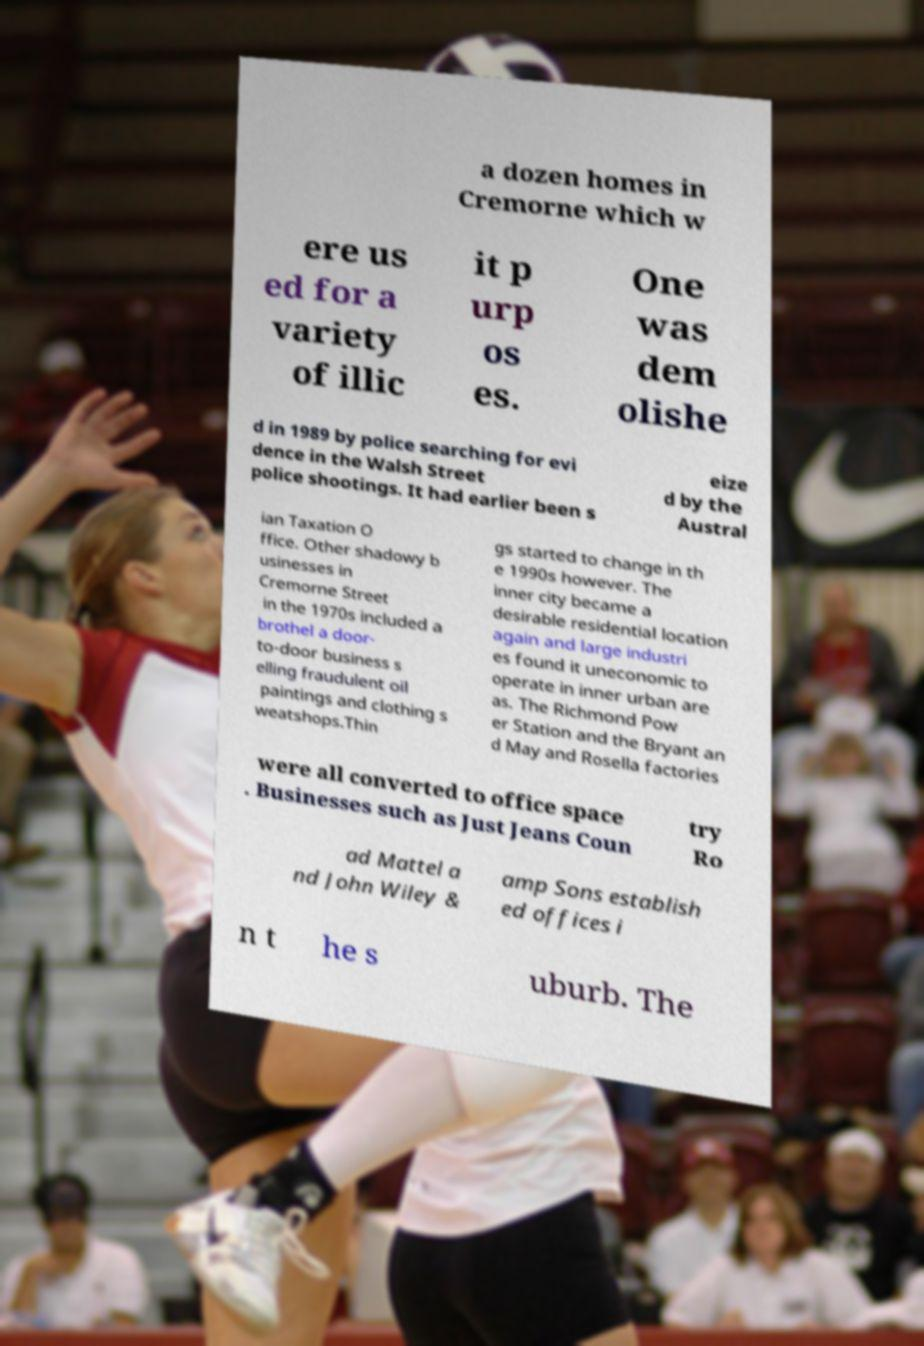There's text embedded in this image that I need extracted. Can you transcribe it verbatim? a dozen homes in Cremorne which w ere us ed for a variety of illic it p urp os es. One was dem olishe d in 1989 by police searching for evi dence in the Walsh Street police shootings. It had earlier been s eize d by the Austral ian Taxation O ffice. Other shadowy b usinesses in Cremorne Street in the 1970s included a brothel a door- to-door business s elling fraudulent oil paintings and clothing s weatshops.Thin gs started to change in th e 1990s however. The inner city became a desirable residential location again and large industri es found it uneconomic to operate in inner urban are as. The Richmond Pow er Station and the Bryant an d May and Rosella factories were all converted to office space . Businesses such as Just Jeans Coun try Ro ad Mattel a nd John Wiley & amp Sons establish ed offices i n t he s uburb. The 